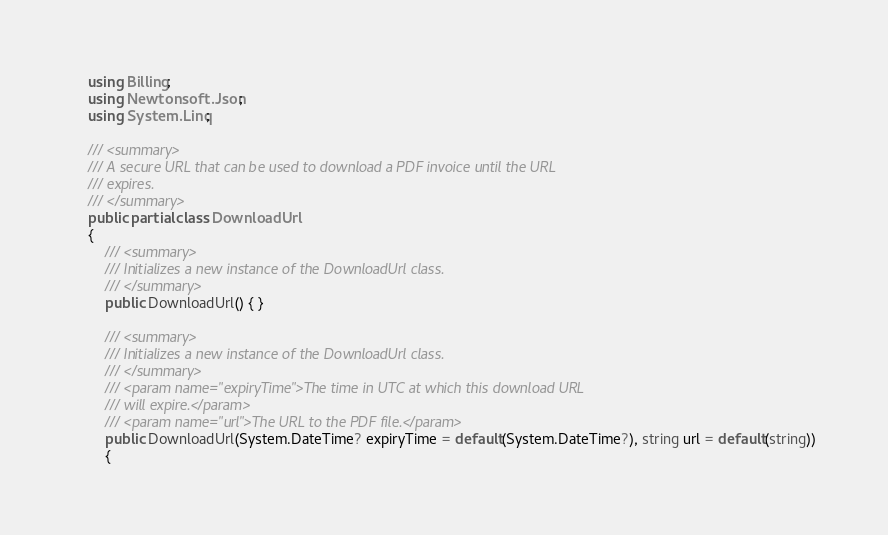<code> <loc_0><loc_0><loc_500><loc_500><_C#_>    using Billing;
    using Newtonsoft.Json;
    using System.Linq;

    /// <summary>
    /// A secure URL that can be used to download a PDF invoice until the URL
    /// expires.
    /// </summary>
    public partial class DownloadUrl
    {
        /// <summary>
        /// Initializes a new instance of the DownloadUrl class.
        /// </summary>
        public DownloadUrl() { }

        /// <summary>
        /// Initializes a new instance of the DownloadUrl class.
        /// </summary>
        /// <param name="expiryTime">The time in UTC at which this download URL
        /// will expire.</param>
        /// <param name="url">The URL to the PDF file.</param>
        public DownloadUrl(System.DateTime? expiryTime = default(System.DateTime?), string url = default(string))
        {</code> 